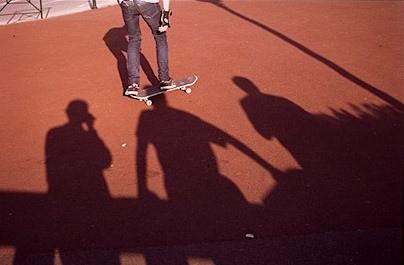What is the person standing on?
Keep it brief. Skateboard. How many shadows do you see?
Be succinct. 4. How many bodies can you see in this image?
Be succinct. 1. 